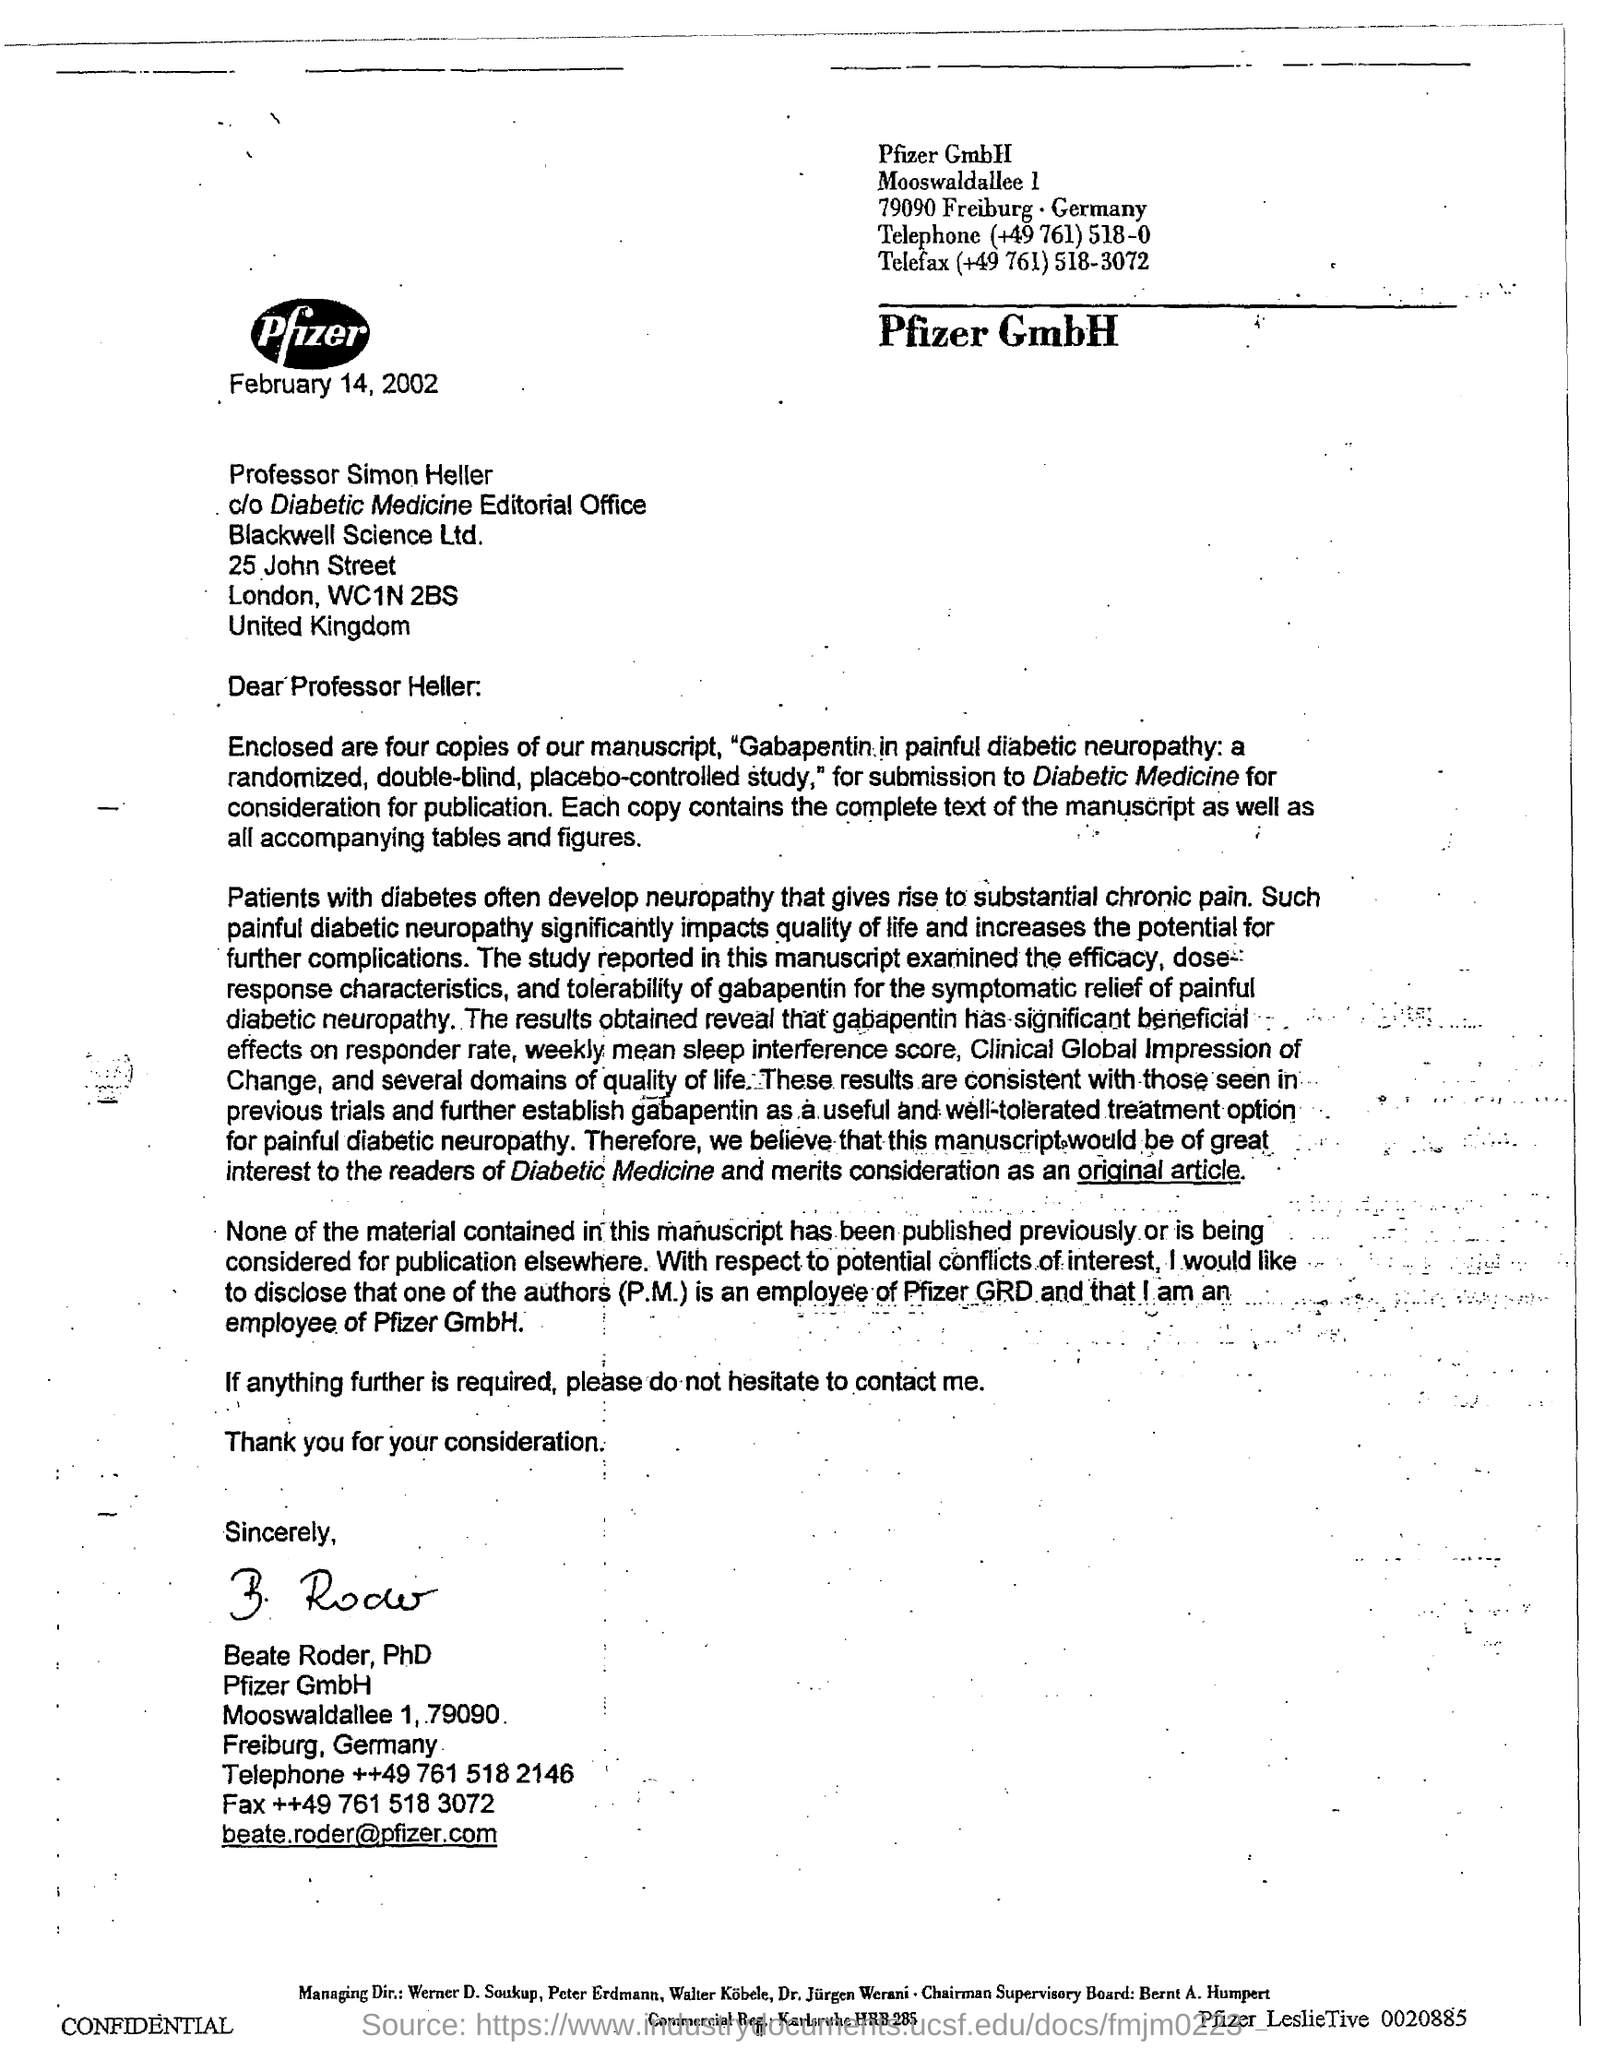Point out several critical features in this image. The date mentioned in this letter is February 14, 2002. Beate Roder, PhD, has signed this letter. 